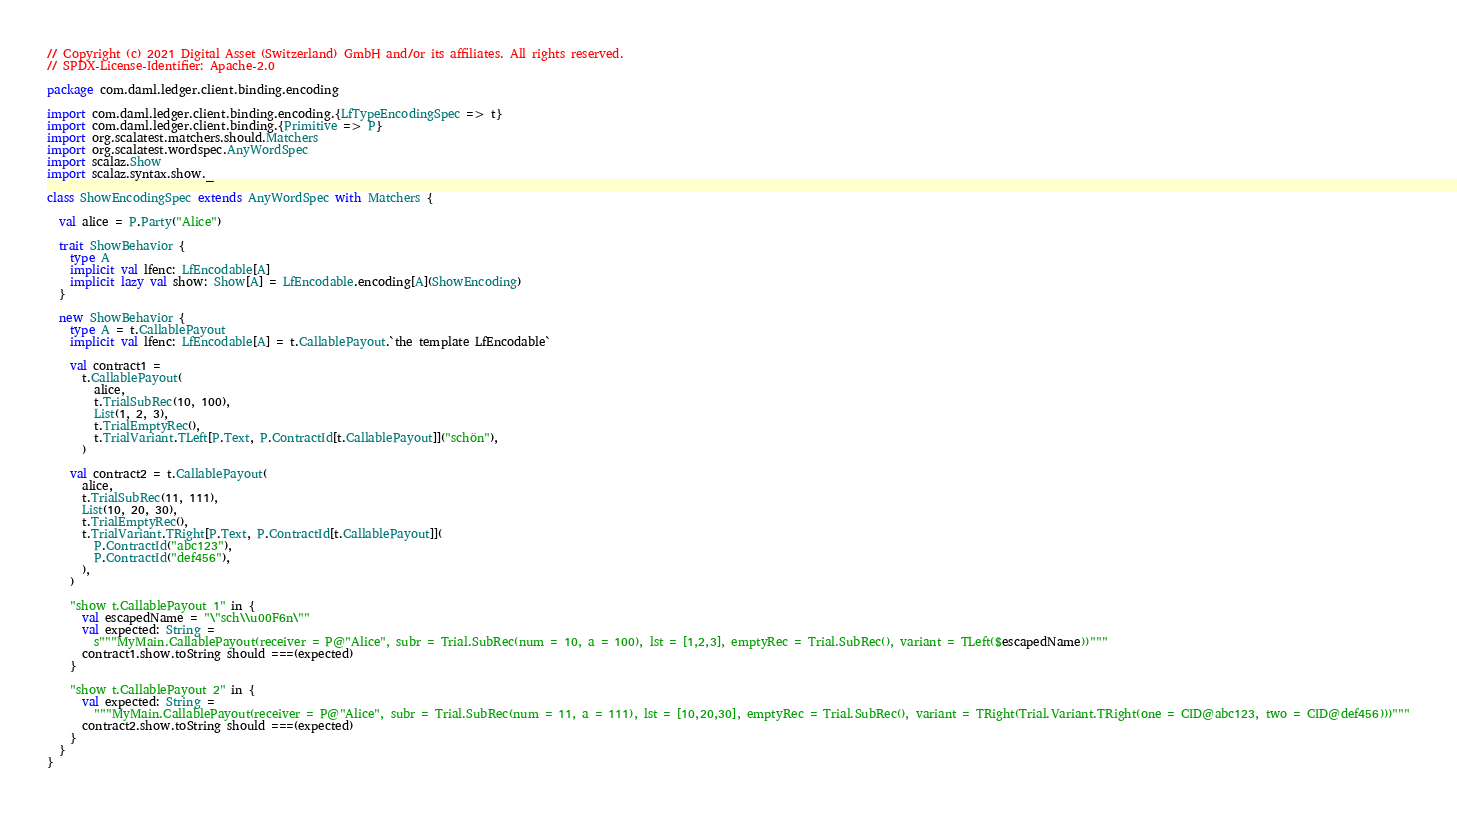Convert code to text. <code><loc_0><loc_0><loc_500><loc_500><_Scala_>// Copyright (c) 2021 Digital Asset (Switzerland) GmbH and/or its affiliates. All rights reserved.
// SPDX-License-Identifier: Apache-2.0

package com.daml.ledger.client.binding.encoding

import com.daml.ledger.client.binding.encoding.{LfTypeEncodingSpec => t}
import com.daml.ledger.client.binding.{Primitive => P}
import org.scalatest.matchers.should.Matchers
import org.scalatest.wordspec.AnyWordSpec
import scalaz.Show
import scalaz.syntax.show._

class ShowEncodingSpec extends AnyWordSpec with Matchers {

  val alice = P.Party("Alice")

  trait ShowBehavior {
    type A
    implicit val lfenc: LfEncodable[A]
    implicit lazy val show: Show[A] = LfEncodable.encoding[A](ShowEncoding)
  }

  new ShowBehavior {
    type A = t.CallablePayout
    implicit val lfenc: LfEncodable[A] = t.CallablePayout.`the template LfEncodable`

    val contract1 =
      t.CallablePayout(
        alice,
        t.TrialSubRec(10, 100),
        List(1, 2, 3),
        t.TrialEmptyRec(),
        t.TrialVariant.TLeft[P.Text, P.ContractId[t.CallablePayout]]("schön"),
      )

    val contract2 = t.CallablePayout(
      alice,
      t.TrialSubRec(11, 111),
      List(10, 20, 30),
      t.TrialEmptyRec(),
      t.TrialVariant.TRight[P.Text, P.ContractId[t.CallablePayout]](
        P.ContractId("abc123"),
        P.ContractId("def456"),
      ),
    )

    "show t.CallablePayout 1" in {
      val escapedName = "\"sch\\u00F6n\""
      val expected: String =
        s"""MyMain.CallablePayout(receiver = P@"Alice", subr = Trial.SubRec(num = 10, a = 100), lst = [1,2,3], emptyRec = Trial.SubRec(), variant = TLeft($escapedName))"""
      contract1.show.toString should ===(expected)
    }

    "show t.CallablePayout 2" in {
      val expected: String =
        """MyMain.CallablePayout(receiver = P@"Alice", subr = Trial.SubRec(num = 11, a = 111), lst = [10,20,30], emptyRec = Trial.SubRec(), variant = TRight(Trial.Variant.TRight(one = CID@abc123, two = CID@def456)))"""
      contract2.show.toString should ===(expected)
    }
  }
}
</code> 